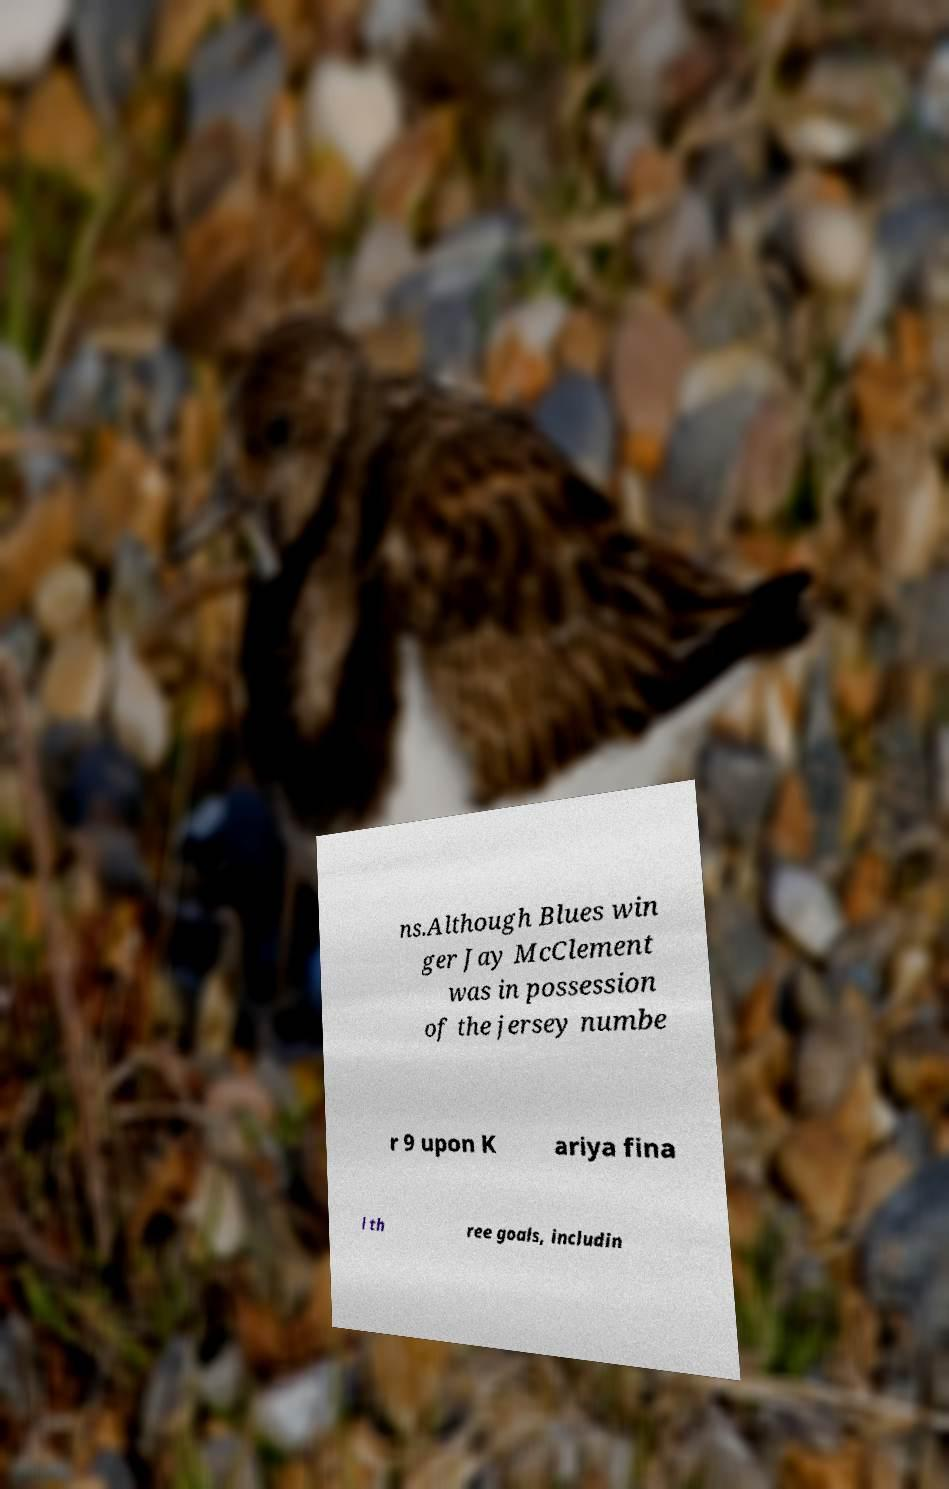There's text embedded in this image that I need extracted. Can you transcribe it verbatim? ns.Although Blues win ger Jay McClement was in possession of the jersey numbe r 9 upon K ariya fina l th ree goals, includin 